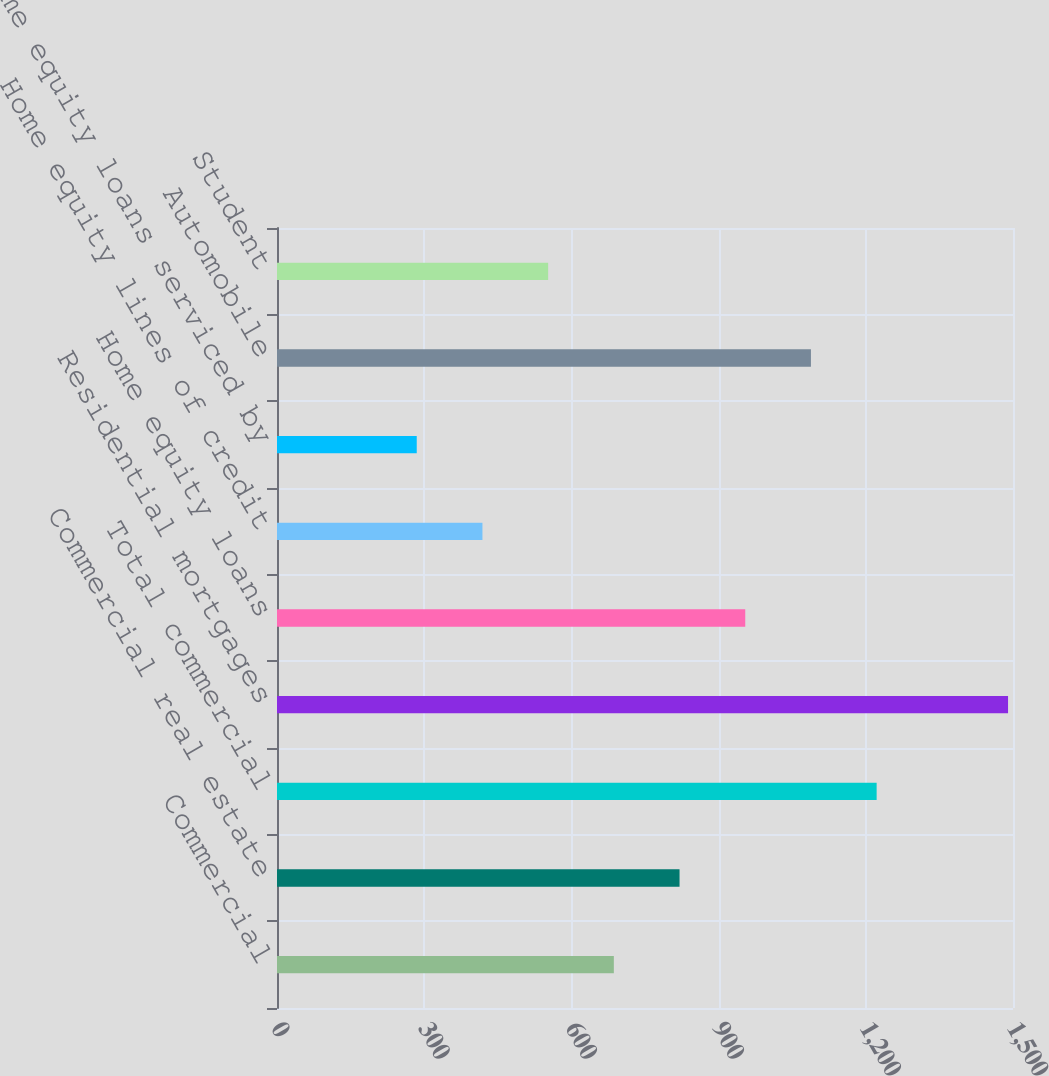<chart> <loc_0><loc_0><loc_500><loc_500><bar_chart><fcel>Commercial<fcel>Commercial real estate<fcel>Total commercial<fcel>Residential mortgages<fcel>Home equity loans<fcel>Home equity lines of credit<fcel>Home equity loans serviced by<fcel>Automobile<fcel>Student<nl><fcel>686.5<fcel>820.4<fcel>1222.1<fcel>1489.9<fcel>954.3<fcel>418.7<fcel>284.8<fcel>1088.2<fcel>552.6<nl></chart> 